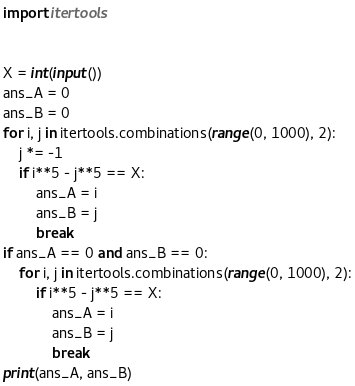<code> <loc_0><loc_0><loc_500><loc_500><_Python_>import itertools


X = int(input())
ans_A = 0
ans_B = 0
for i, j in itertools.combinations(range(0, 1000), 2):
    j *= -1
    if i**5 - j**5 == X:
        ans_A = i
        ans_B = j
        break
if ans_A == 0 and ans_B == 0:
    for i, j in itertools.combinations(range(0, 1000), 2):
        if i**5 - j**5 == X:
            ans_A = i
            ans_B = j
            break
print(ans_A, ans_B)
</code> 